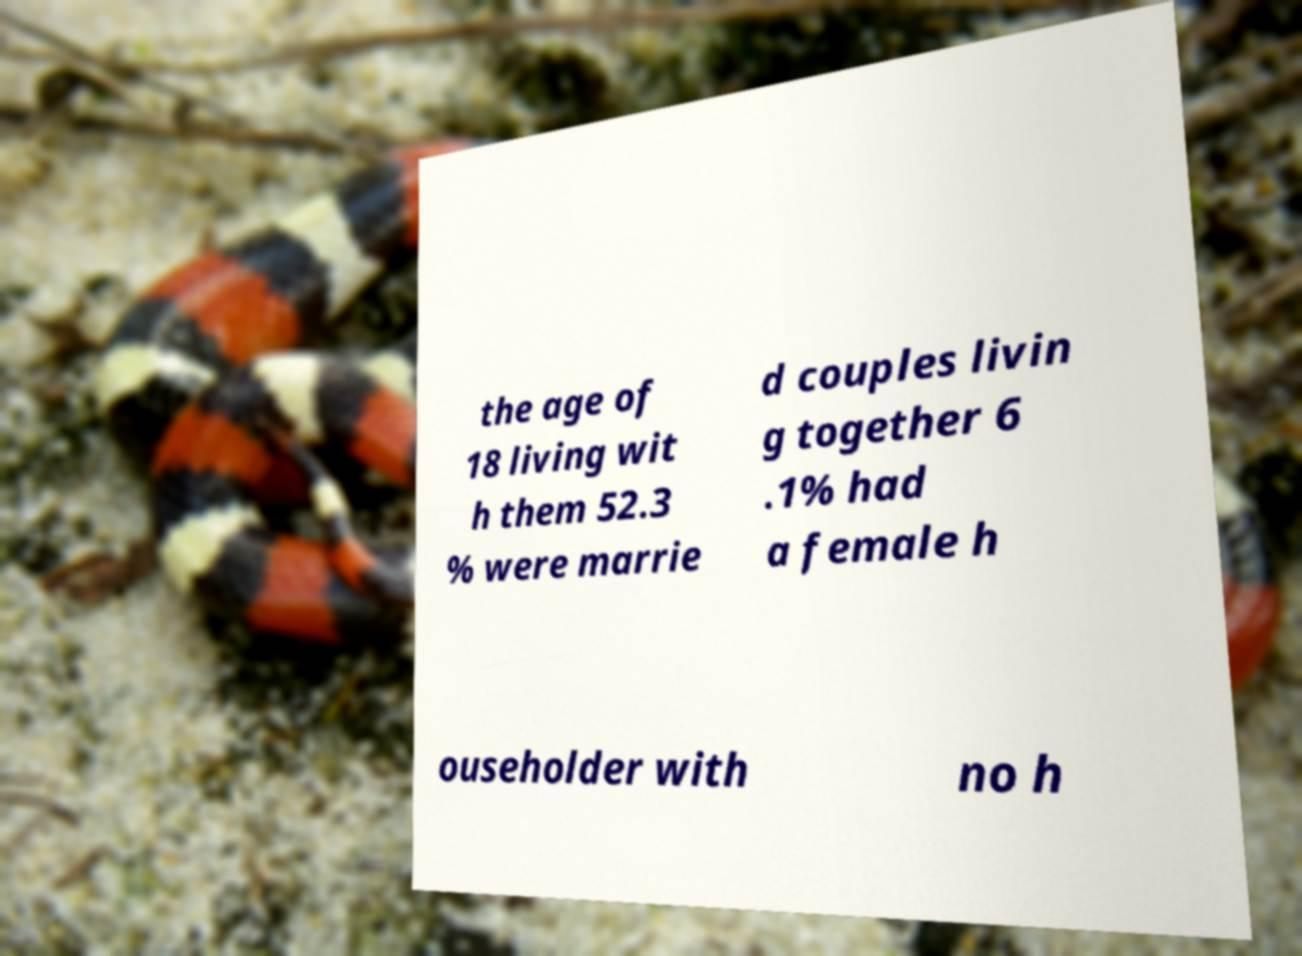I need the written content from this picture converted into text. Can you do that? the age of 18 living wit h them 52.3 % were marrie d couples livin g together 6 .1% had a female h ouseholder with no h 